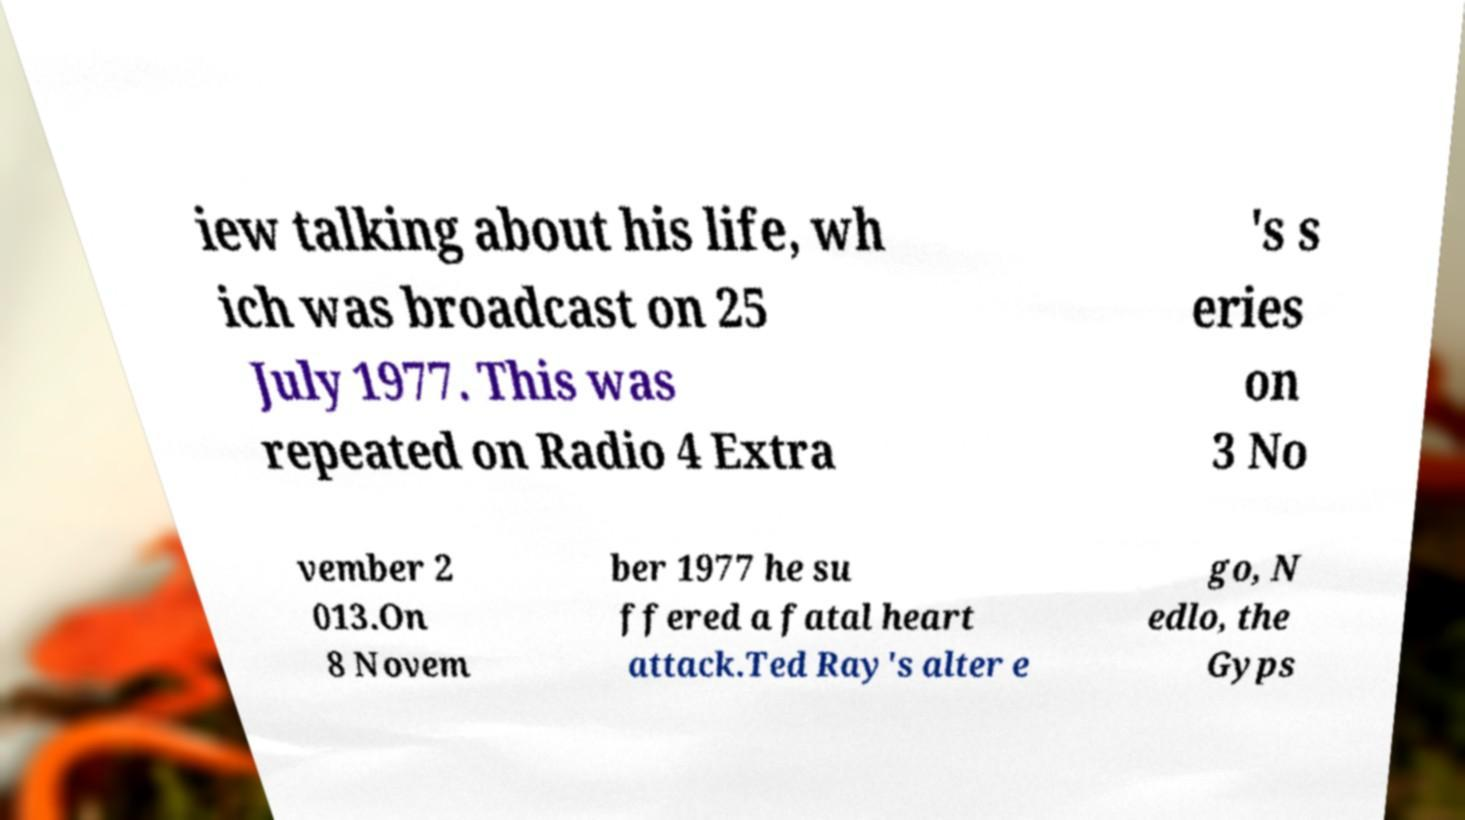Can you accurately transcribe the text from the provided image for me? iew talking about his life, wh ich was broadcast on 25 July 1977. This was repeated on Radio 4 Extra 's s eries on 3 No vember 2 013.On 8 Novem ber 1977 he su ffered a fatal heart attack.Ted Ray's alter e go, N edlo, the Gyps 